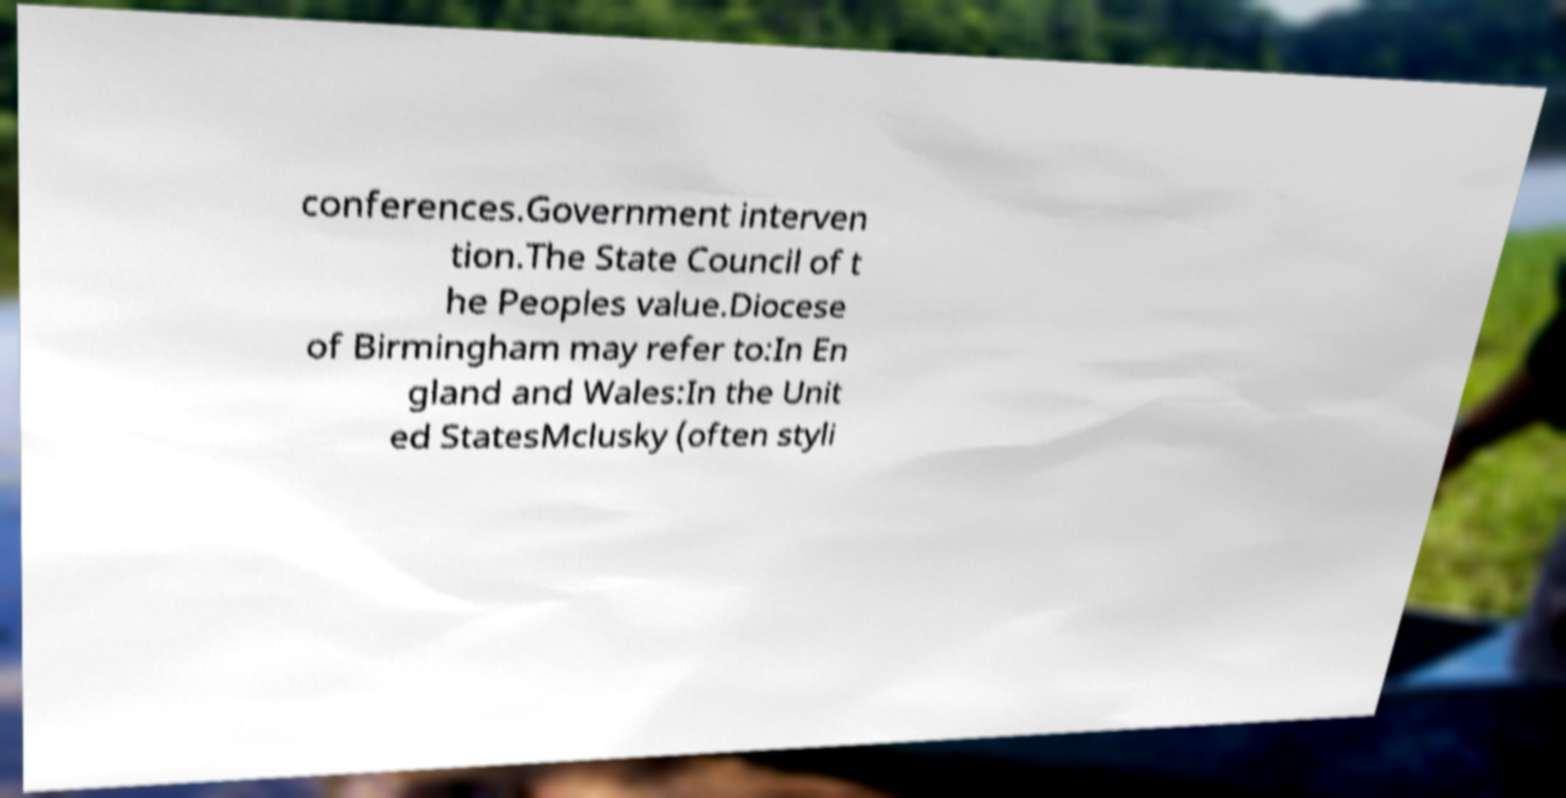Can you accurately transcribe the text from the provided image for me? conferences.Government interven tion.The State Council of t he Peoples value.Diocese of Birmingham may refer to:In En gland and Wales:In the Unit ed StatesMclusky (often styli 